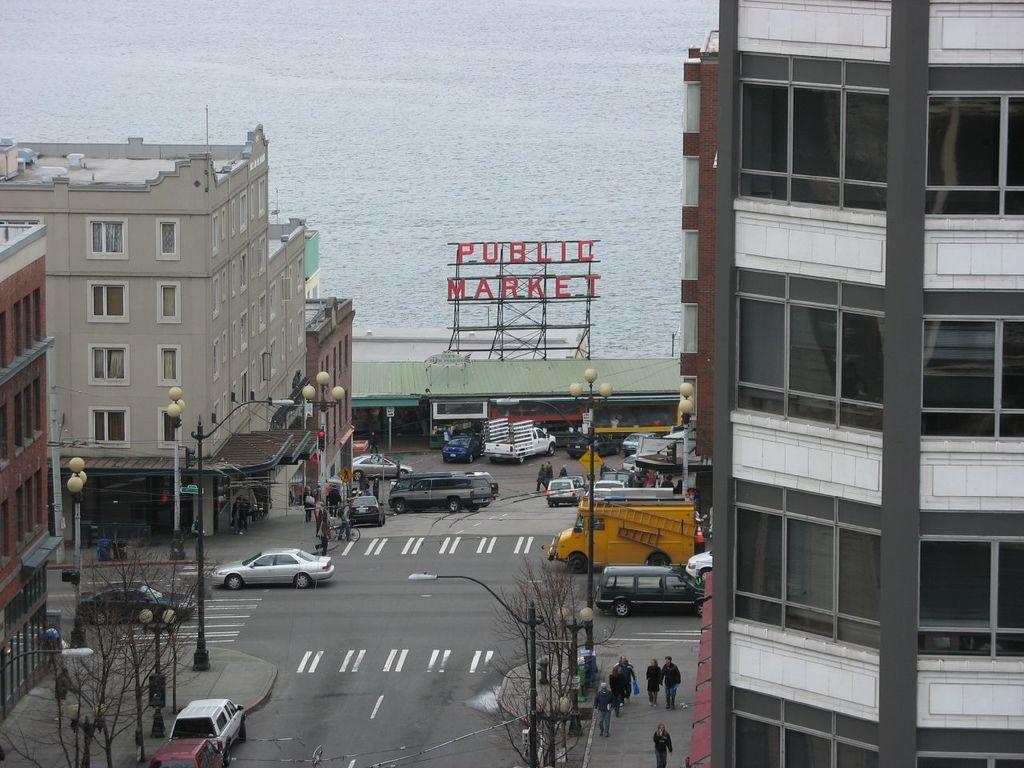How would you summarize this image in a sentence or two? In this image we can see a group of buildings with windows, a group of vehicles parked on the road, we can also see some ladders on a vehicle. In the foreground of the image we can see a group of people standing on the ground, groups of trees and some light poles. In the center of the image we can see a signboard with some text on metal frames. At the top of the image we can see water. 